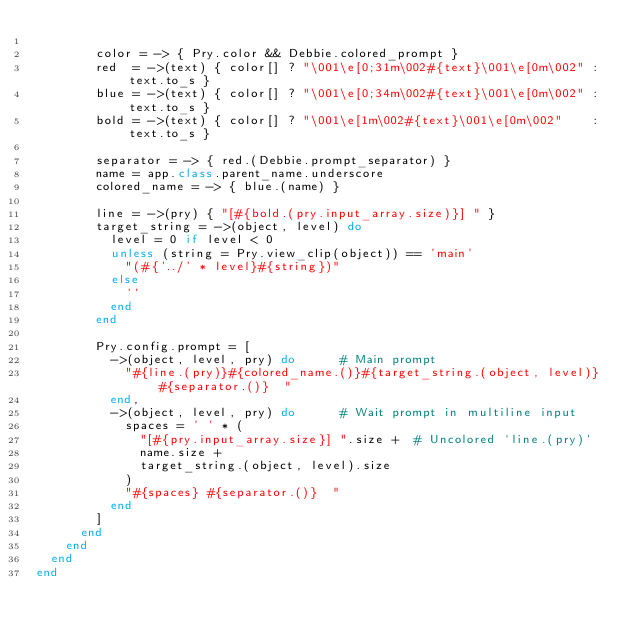Convert code to text. <code><loc_0><loc_0><loc_500><loc_500><_Ruby_>
        color = -> { Pry.color && Debbie.colored_prompt }
        red  = ->(text) { color[] ? "\001\e[0;31m\002#{text}\001\e[0m\002" : text.to_s }
        blue = ->(text) { color[] ? "\001\e[0;34m\002#{text}\001\e[0m\002" : text.to_s }
        bold = ->(text) { color[] ? "\001\e[1m\002#{text}\001\e[0m\002"    : text.to_s }

        separator = -> { red.(Debbie.prompt_separator) }
        name = app.class.parent_name.underscore
        colored_name = -> { blue.(name) }

        line = ->(pry) { "[#{bold.(pry.input_array.size)}] " }
        target_string = ->(object, level) do
          level = 0 if level < 0
          unless (string = Pry.view_clip(object)) == 'main'
            "(#{'../' * level}#{string})"
          else
            ''
          end
        end

        Pry.config.prompt = [
          ->(object, level, pry) do      # Main prompt
            "#{line.(pry)}#{colored_name.()}#{target_string.(object, level)} #{separator.()}  "
          end,
          ->(object, level, pry) do      # Wait prompt in multiline input
            spaces = ' ' * (
              "[#{pry.input_array.size}] ".size +  # Uncolored `line.(pry)`
              name.size +
              target_string.(object, level).size
            )
            "#{spaces} #{separator.()}  "
          end
        ]
      end
    end
  end
end
</code> 